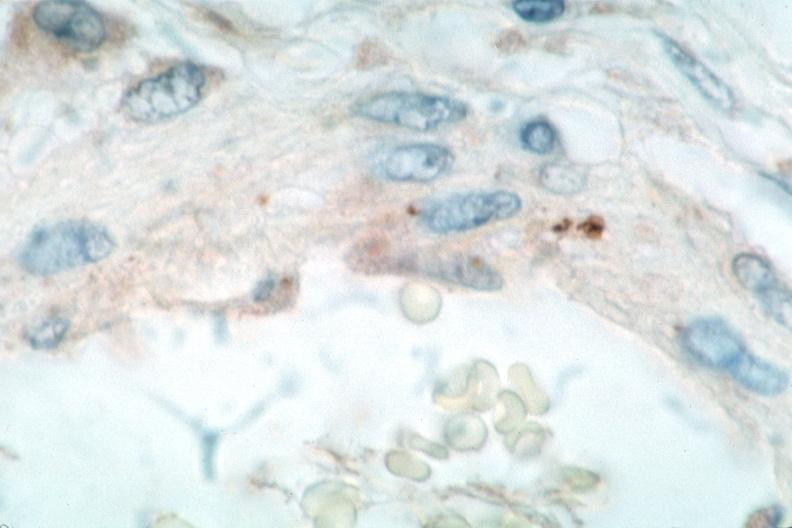what is vasculitis , rocky mountain spotted?
Answer the question using a single word or phrase. Fever immunoperoxidase staining vessels for rickettsia rickettsii 